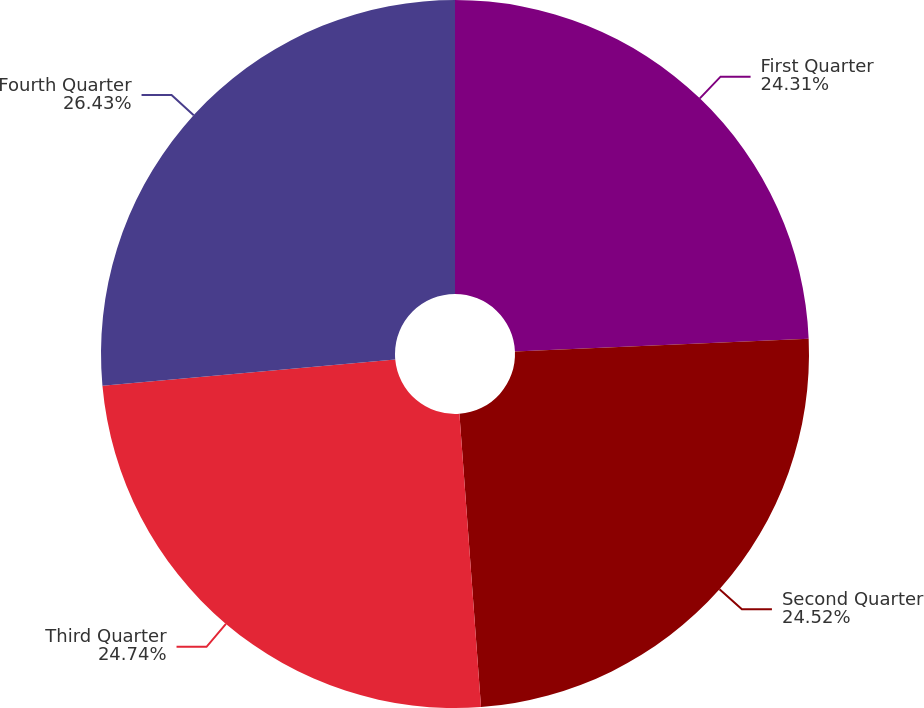Convert chart. <chart><loc_0><loc_0><loc_500><loc_500><pie_chart><fcel>First Quarter<fcel>Second Quarter<fcel>Third Quarter<fcel>Fourth Quarter<nl><fcel>24.31%<fcel>24.52%<fcel>24.74%<fcel>26.43%<nl></chart> 